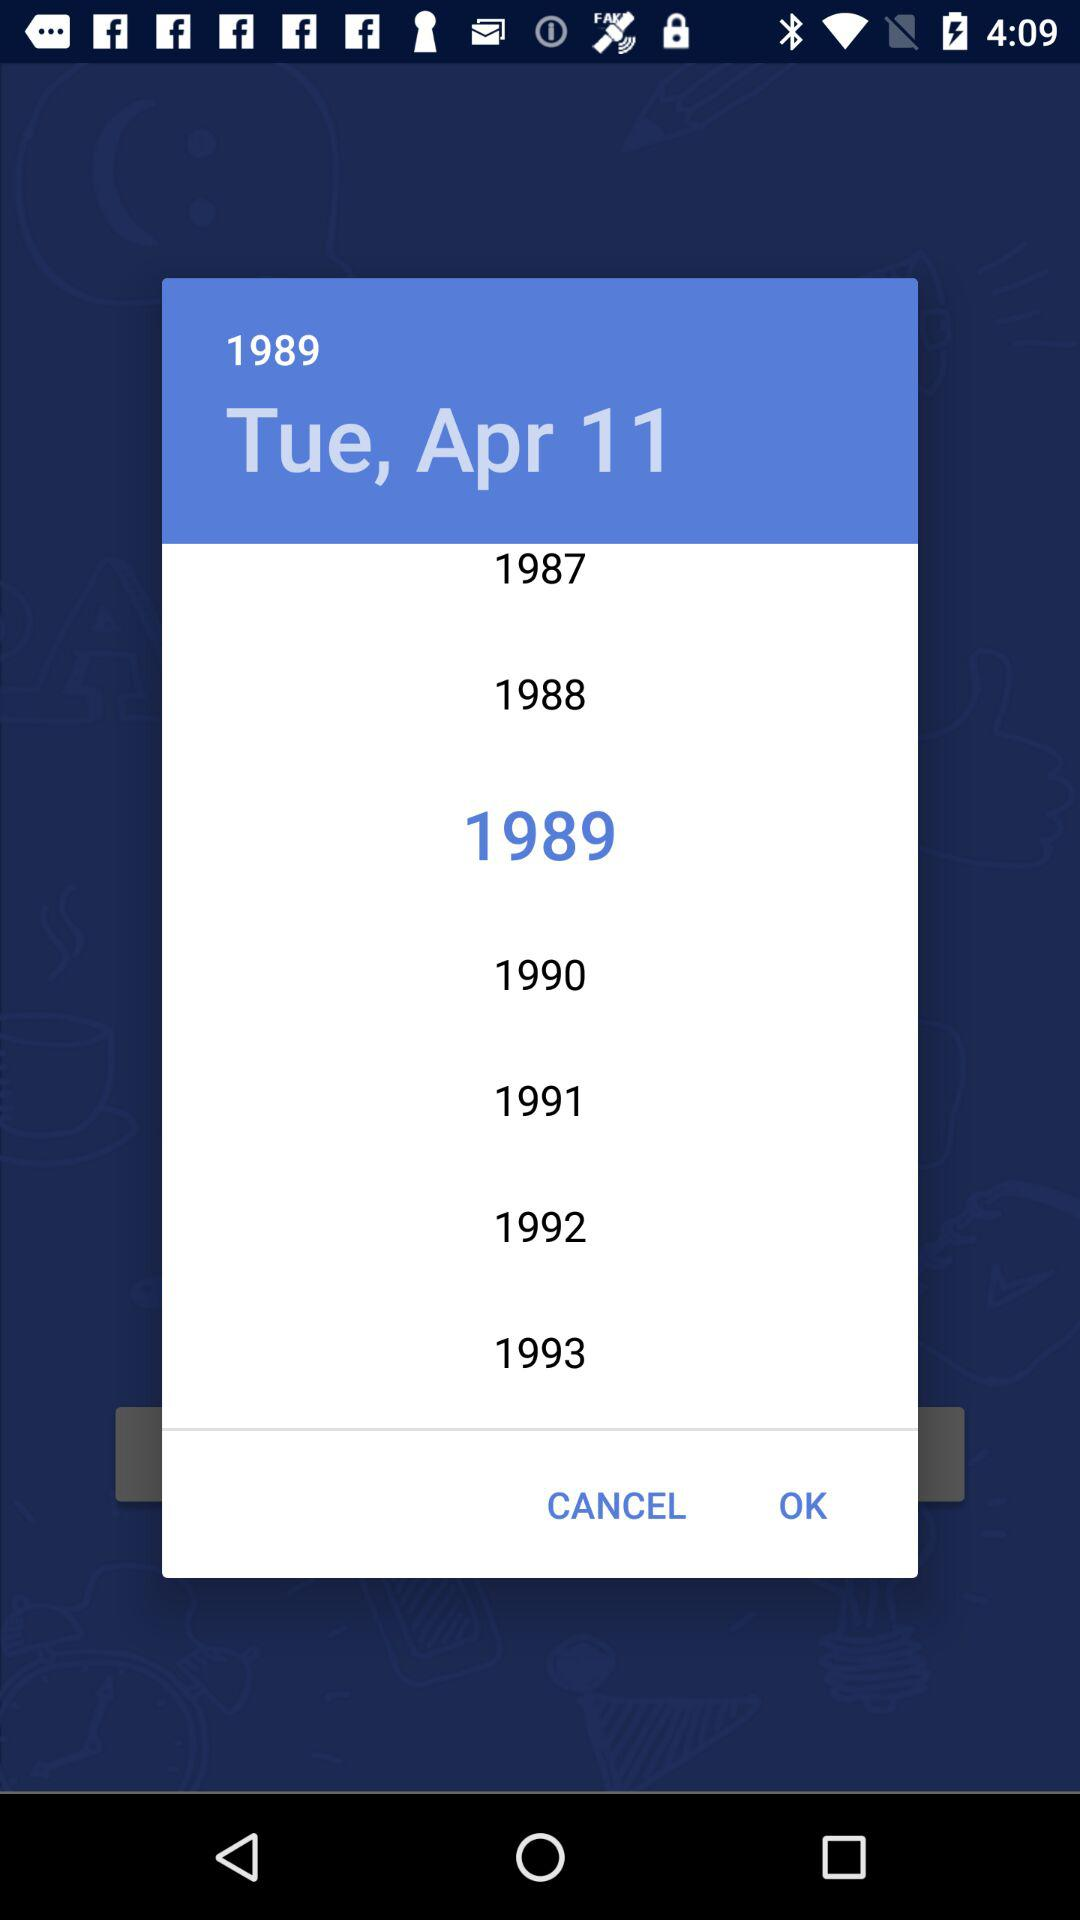What is the selected year? The selected year is 1989. 